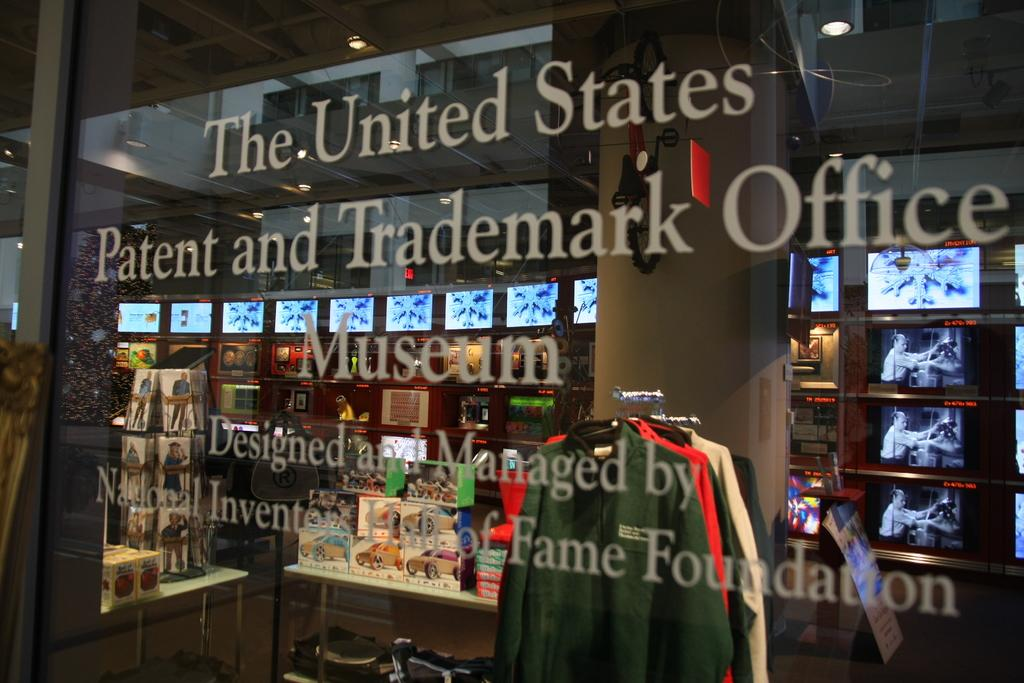<image>
Write a terse but informative summary of the picture. The United States Patent and Trademark Office Museum window is in front of many view screens. 